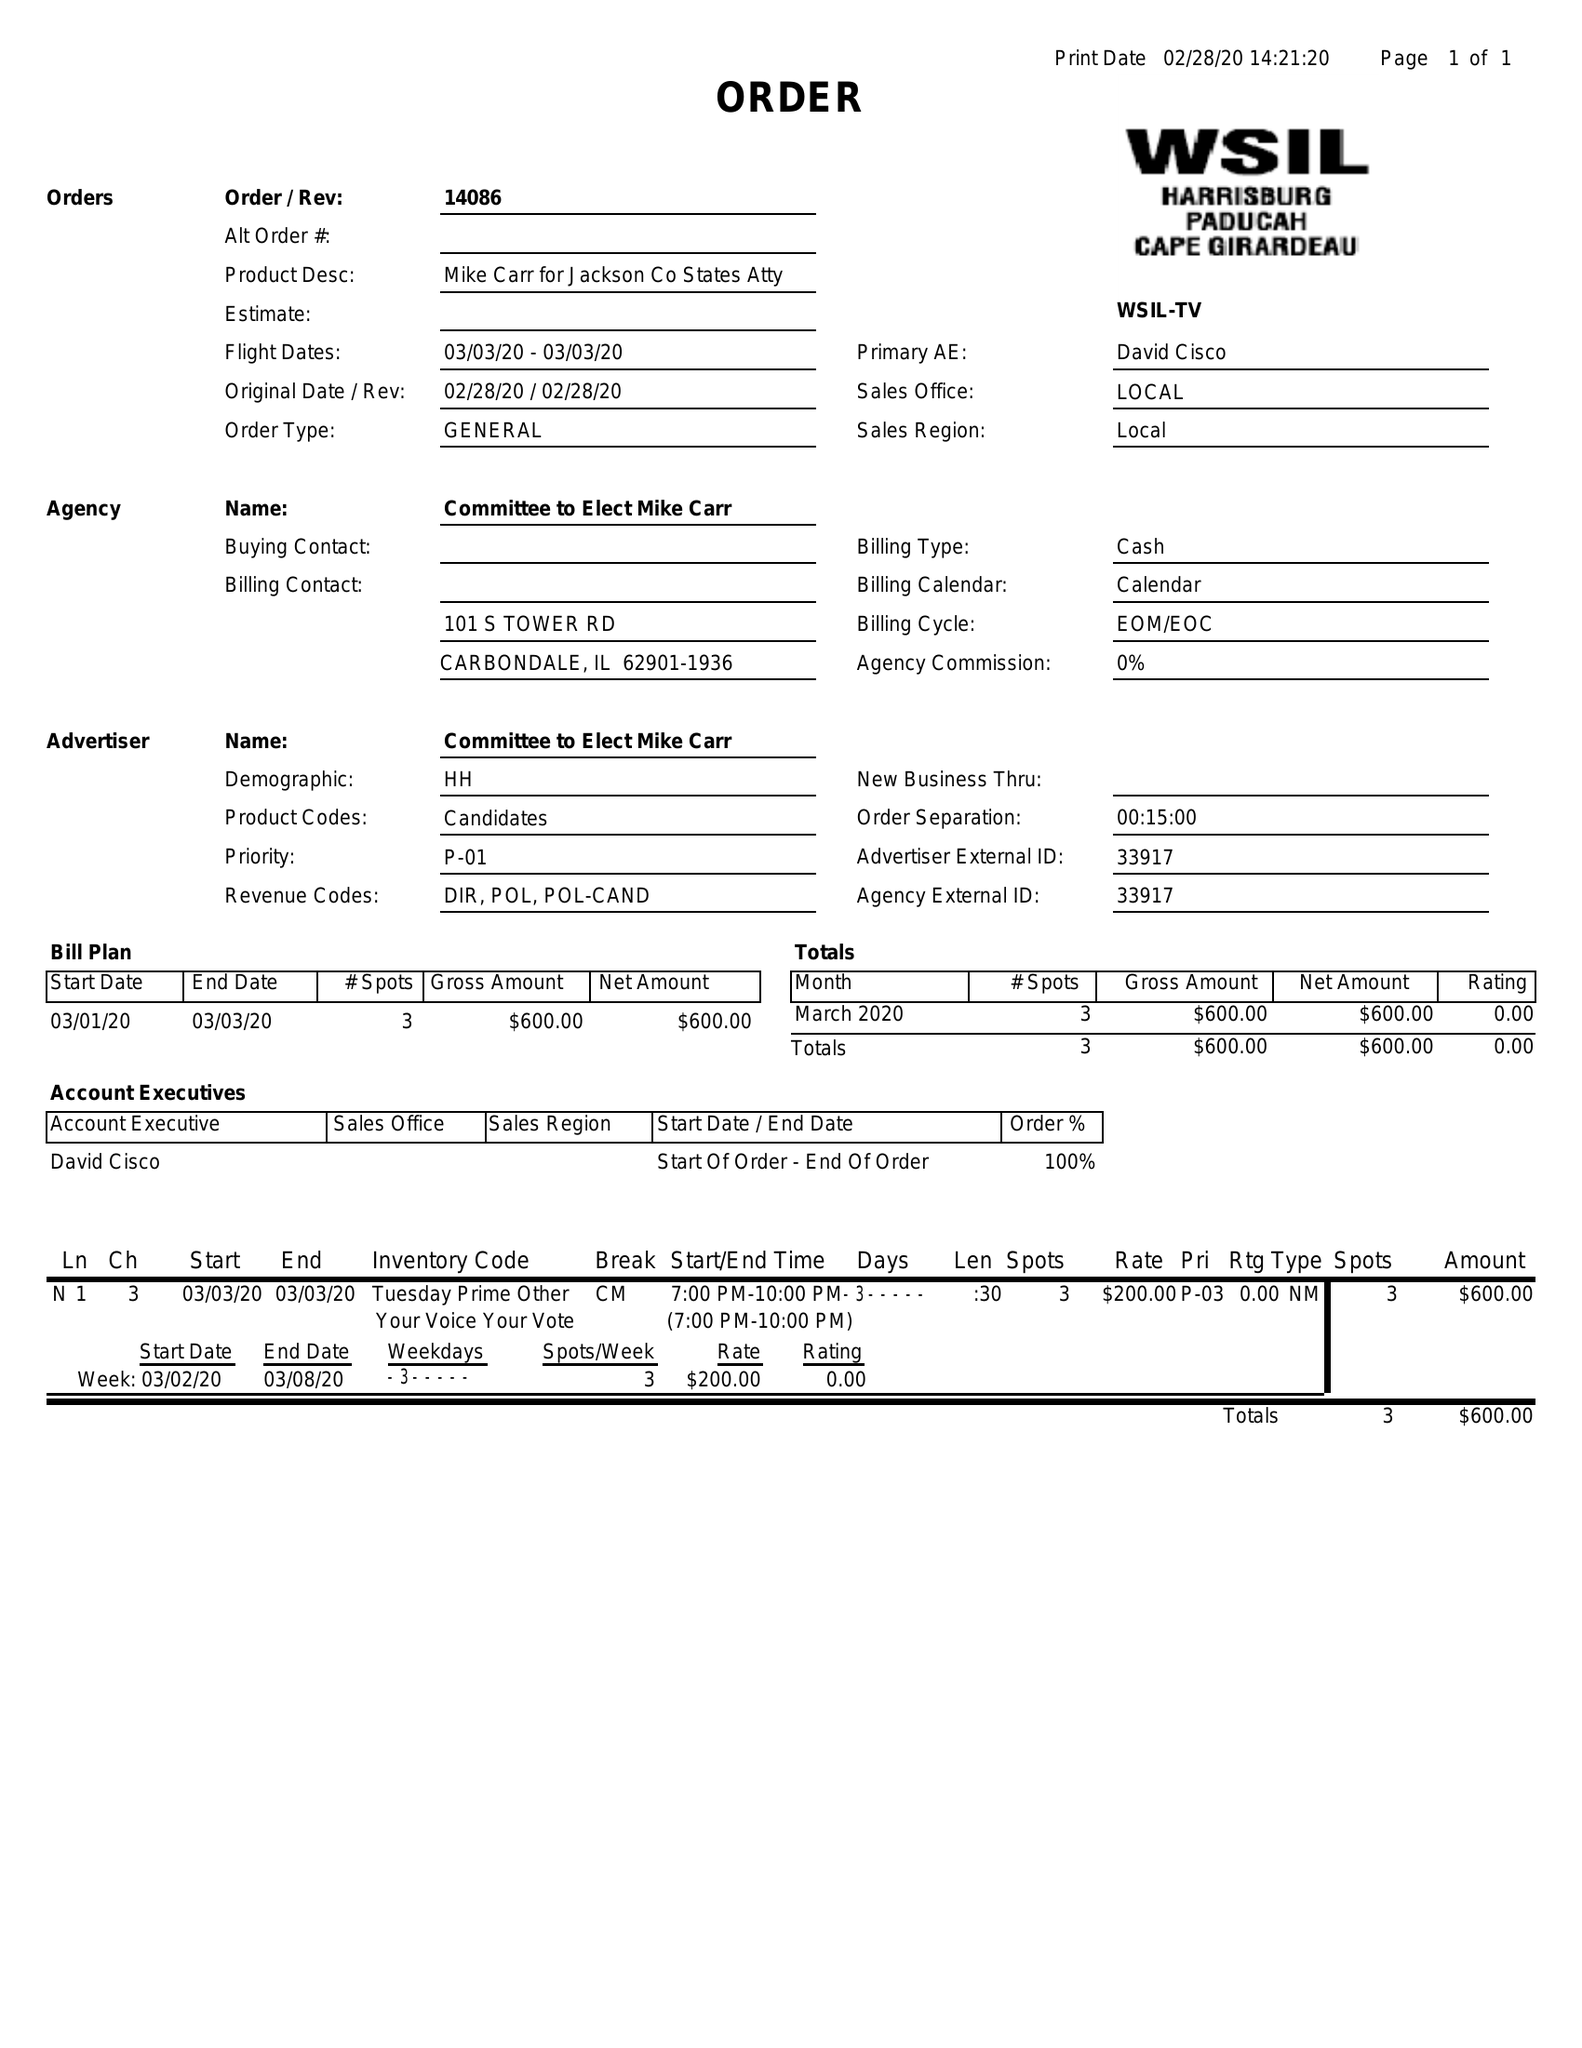What is the value for the gross_amount?
Answer the question using a single word or phrase. 600.00 